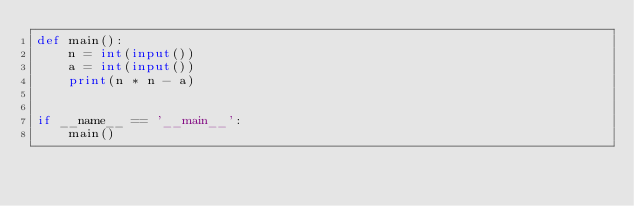Convert code to text. <code><loc_0><loc_0><loc_500><loc_500><_Python_>def main():
    n = int(input())
    a = int(input())
    print(n * n - a)


if __name__ == '__main__':
    main()
</code> 